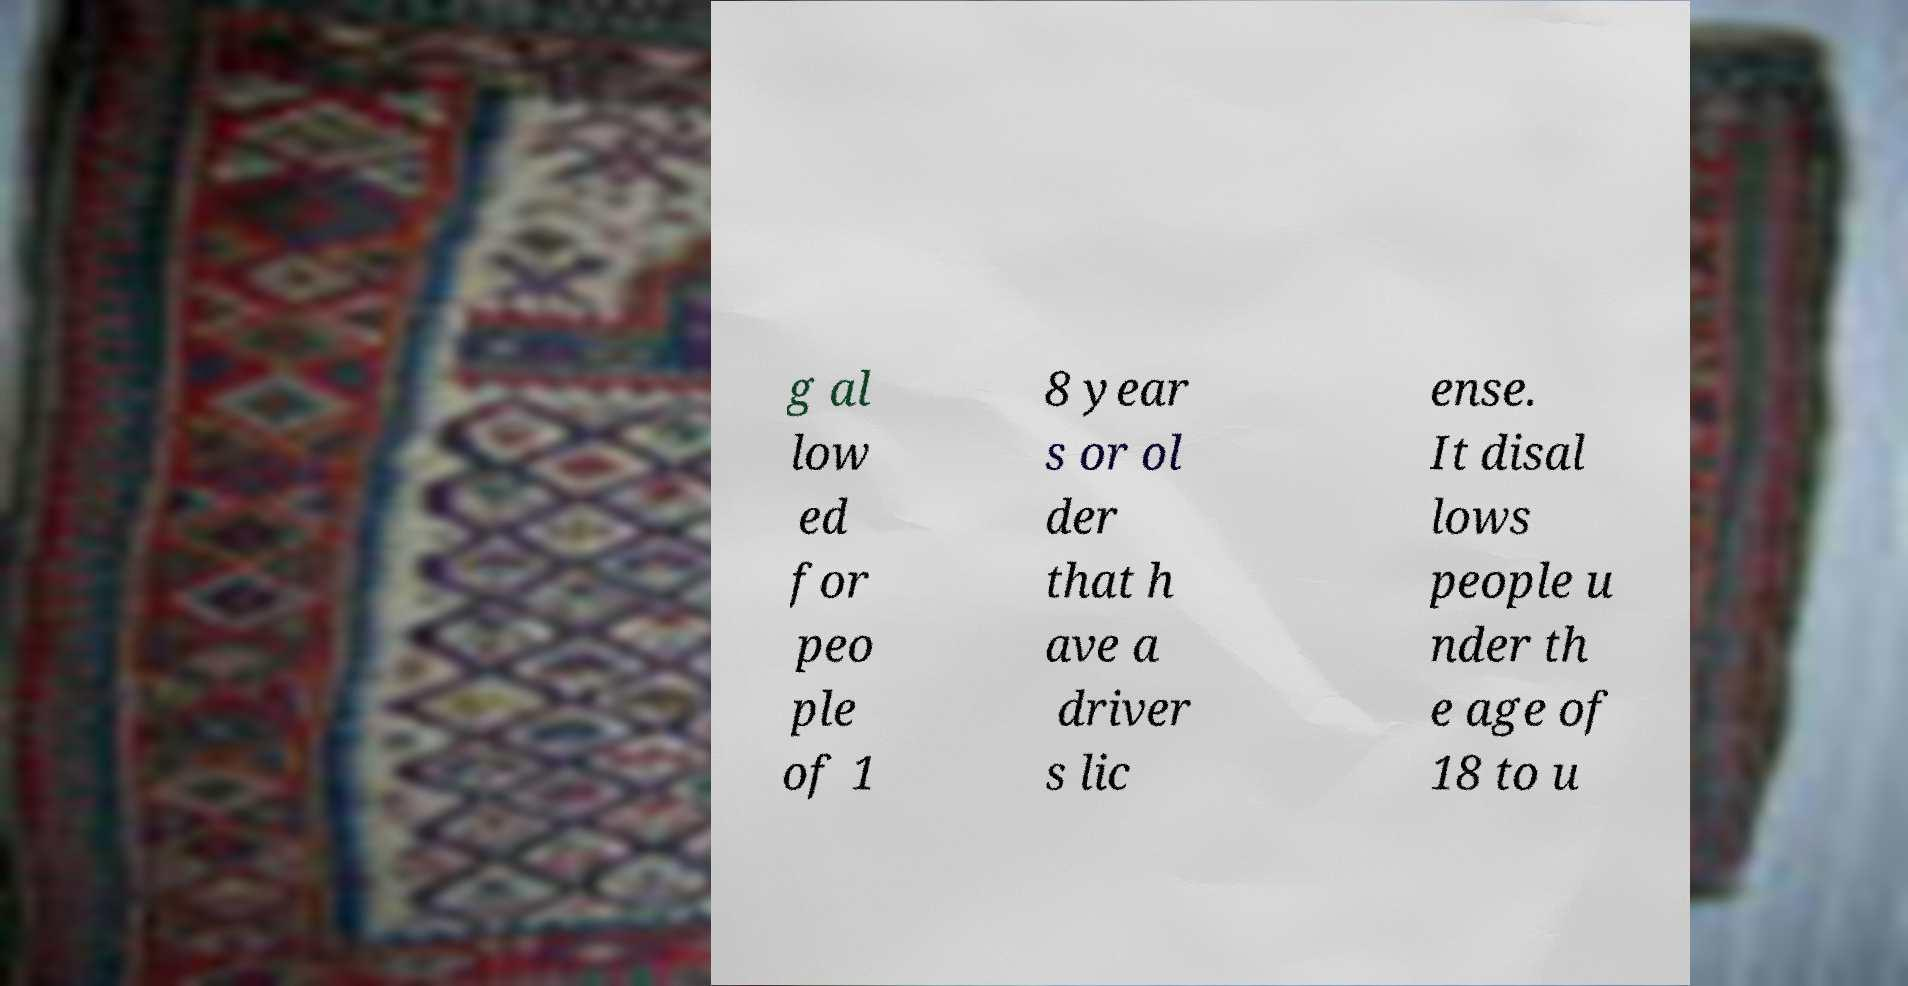Could you assist in decoding the text presented in this image and type it out clearly? g al low ed for peo ple of 1 8 year s or ol der that h ave a driver s lic ense. It disal lows people u nder th e age of 18 to u 